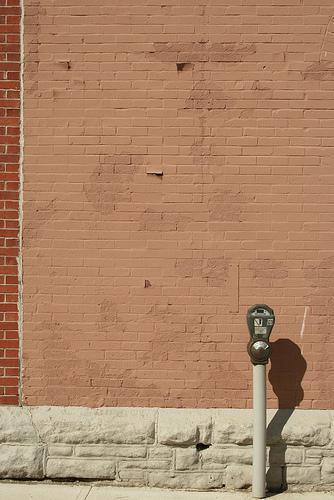How many trees are in this picture?
Give a very brief answer. 0. 